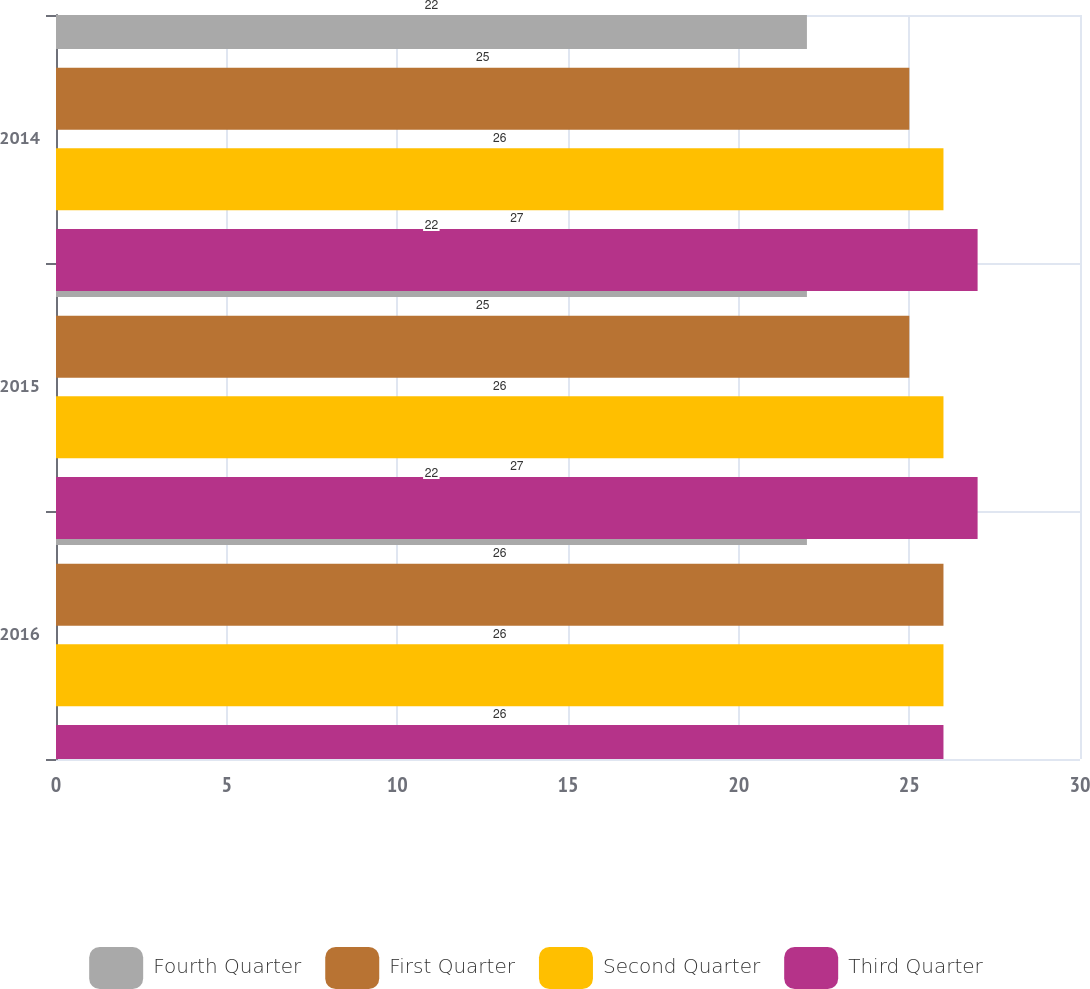Convert chart to OTSL. <chart><loc_0><loc_0><loc_500><loc_500><stacked_bar_chart><ecel><fcel>2016<fcel>2015<fcel>2014<nl><fcel>Fourth Quarter<fcel>22<fcel>22<fcel>22<nl><fcel>First Quarter<fcel>26<fcel>25<fcel>25<nl><fcel>Second Quarter<fcel>26<fcel>26<fcel>26<nl><fcel>Third Quarter<fcel>26<fcel>27<fcel>27<nl></chart> 